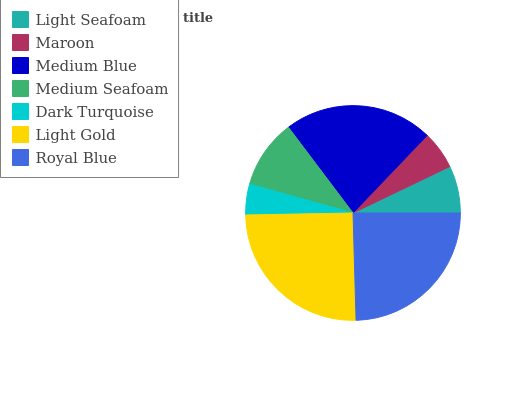Is Dark Turquoise the minimum?
Answer yes or no. Yes. Is Light Gold the maximum?
Answer yes or no. Yes. Is Maroon the minimum?
Answer yes or no. No. Is Maroon the maximum?
Answer yes or no. No. Is Light Seafoam greater than Maroon?
Answer yes or no. Yes. Is Maroon less than Light Seafoam?
Answer yes or no. Yes. Is Maroon greater than Light Seafoam?
Answer yes or no. No. Is Light Seafoam less than Maroon?
Answer yes or no. No. Is Medium Seafoam the high median?
Answer yes or no. Yes. Is Medium Seafoam the low median?
Answer yes or no. Yes. Is Dark Turquoise the high median?
Answer yes or no. No. Is Light Gold the low median?
Answer yes or no. No. 